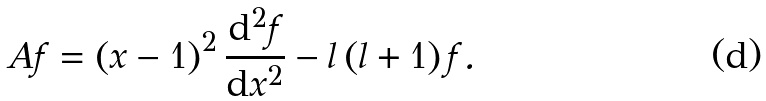<formula> <loc_0><loc_0><loc_500><loc_500>A f = \left ( x - 1 \right ) ^ { 2 } \frac { { \mathrm d } ^ { 2 } f } { { \mathrm d } x ^ { 2 } } - l \left ( l + 1 \right ) f .</formula> 